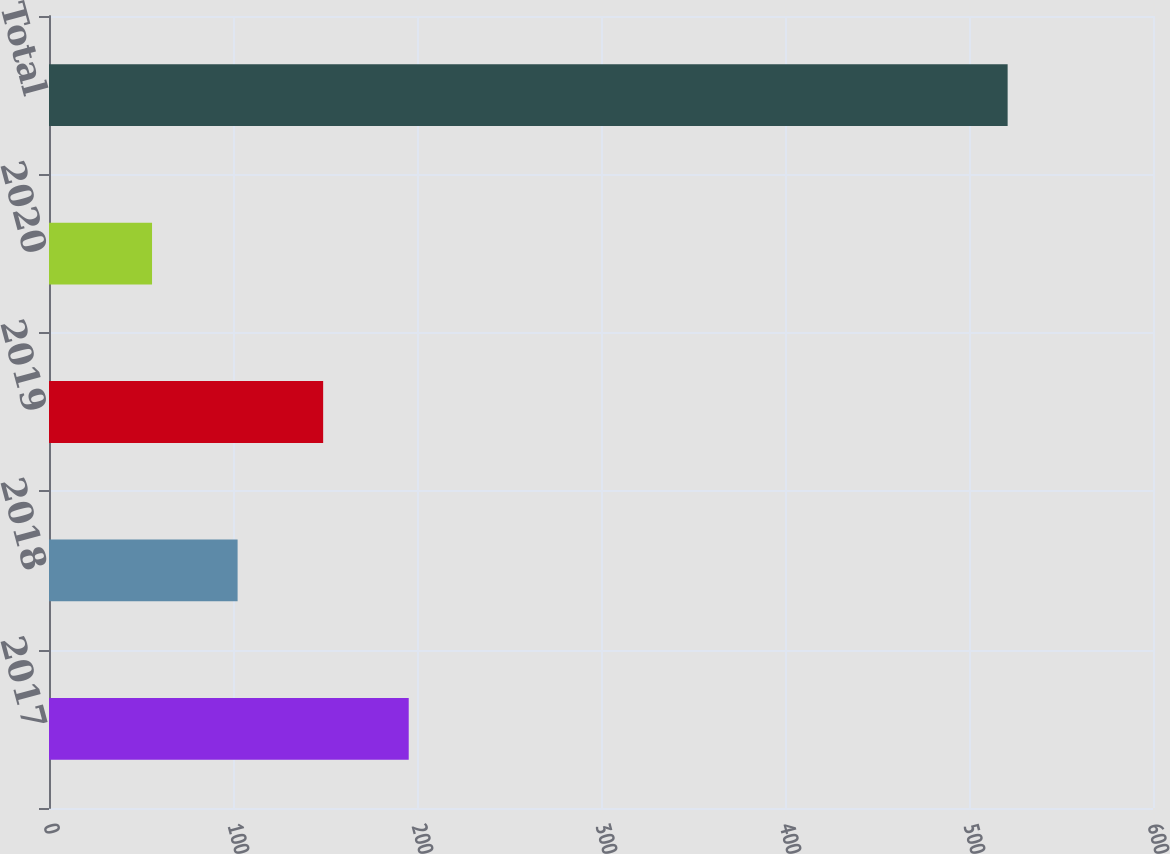<chart> <loc_0><loc_0><loc_500><loc_500><bar_chart><fcel>2017<fcel>2018<fcel>2019<fcel>2020<fcel>Total<nl><fcel>195.5<fcel>102.5<fcel>149<fcel>56<fcel>521<nl></chart> 